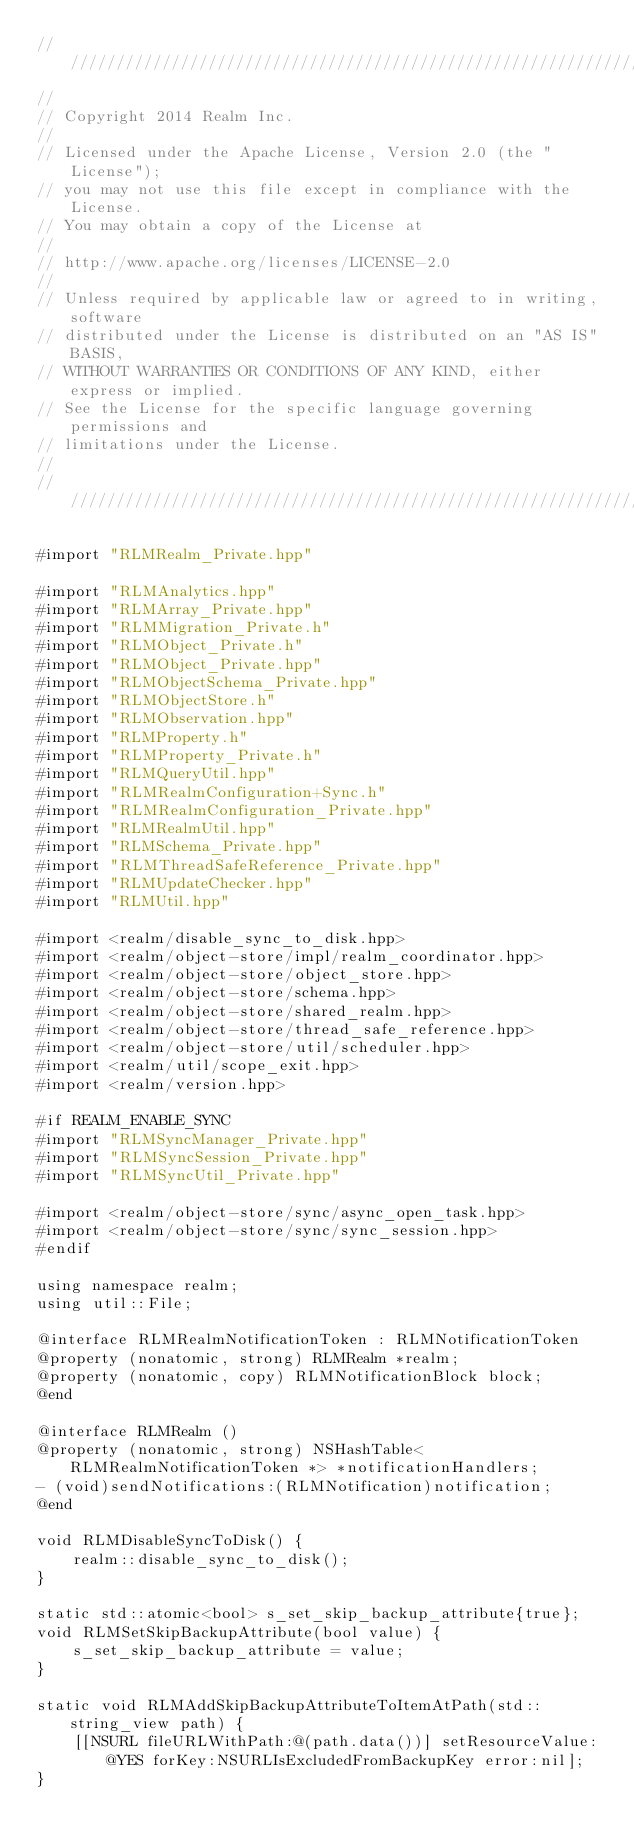Convert code to text. <code><loc_0><loc_0><loc_500><loc_500><_ObjectiveC_>////////////////////////////////////////////////////////////////////////////
//
// Copyright 2014 Realm Inc.
//
// Licensed under the Apache License, Version 2.0 (the "License");
// you may not use this file except in compliance with the License.
// You may obtain a copy of the License at
//
// http://www.apache.org/licenses/LICENSE-2.0
//
// Unless required by applicable law or agreed to in writing, software
// distributed under the License is distributed on an "AS IS" BASIS,
// WITHOUT WARRANTIES OR CONDITIONS OF ANY KIND, either express or implied.
// See the License for the specific language governing permissions and
// limitations under the License.
//
////////////////////////////////////////////////////////////////////////////

#import "RLMRealm_Private.hpp"

#import "RLMAnalytics.hpp"
#import "RLMArray_Private.hpp"
#import "RLMMigration_Private.h"
#import "RLMObject_Private.h"
#import "RLMObject_Private.hpp"
#import "RLMObjectSchema_Private.hpp"
#import "RLMObjectStore.h"
#import "RLMObservation.hpp"
#import "RLMProperty.h"
#import "RLMProperty_Private.h"
#import "RLMQueryUtil.hpp"
#import "RLMRealmConfiguration+Sync.h"
#import "RLMRealmConfiguration_Private.hpp"
#import "RLMRealmUtil.hpp"
#import "RLMSchema_Private.hpp"
#import "RLMThreadSafeReference_Private.hpp"
#import "RLMUpdateChecker.hpp"
#import "RLMUtil.hpp"

#import <realm/disable_sync_to_disk.hpp>
#import <realm/object-store/impl/realm_coordinator.hpp>
#import <realm/object-store/object_store.hpp>
#import <realm/object-store/schema.hpp>
#import <realm/object-store/shared_realm.hpp>
#import <realm/object-store/thread_safe_reference.hpp>
#import <realm/object-store/util/scheduler.hpp>
#import <realm/util/scope_exit.hpp>
#import <realm/version.hpp>

#if REALM_ENABLE_SYNC
#import "RLMSyncManager_Private.hpp"
#import "RLMSyncSession_Private.hpp"
#import "RLMSyncUtil_Private.hpp"

#import <realm/object-store/sync/async_open_task.hpp>
#import <realm/object-store/sync/sync_session.hpp>
#endif

using namespace realm;
using util::File;

@interface RLMRealmNotificationToken : RLMNotificationToken
@property (nonatomic, strong) RLMRealm *realm;
@property (nonatomic, copy) RLMNotificationBlock block;
@end

@interface RLMRealm ()
@property (nonatomic, strong) NSHashTable<RLMRealmNotificationToken *> *notificationHandlers;
- (void)sendNotifications:(RLMNotification)notification;
@end

void RLMDisableSyncToDisk() {
    realm::disable_sync_to_disk();
}

static std::atomic<bool> s_set_skip_backup_attribute{true};
void RLMSetSkipBackupAttribute(bool value) {
    s_set_skip_backup_attribute = value;
}

static void RLMAddSkipBackupAttributeToItemAtPath(std::string_view path) {
    [[NSURL fileURLWithPath:@(path.data())] setResourceValue:@YES forKey:NSURLIsExcludedFromBackupKey error:nil];
}
</code> 